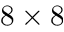Convert formula to latex. <formula><loc_0><loc_0><loc_500><loc_500>8 \times 8</formula> 